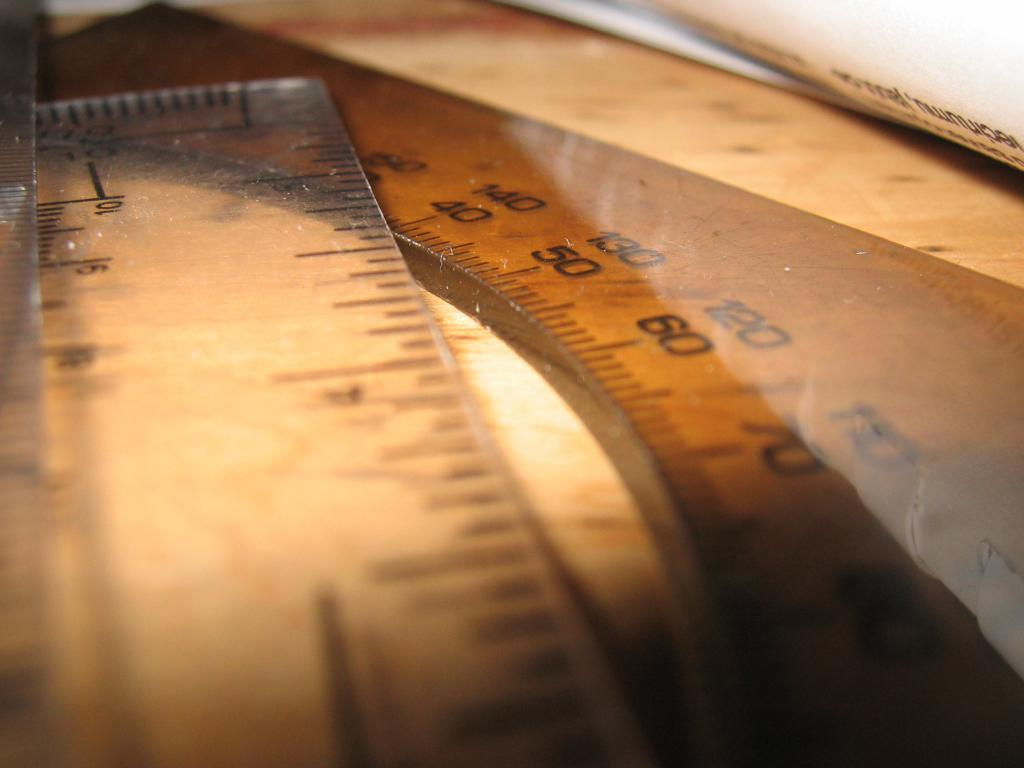<image>
Give a short and clear explanation of the subsequent image. A measuring devices with numbers including 40, 50, 60 and 70. 